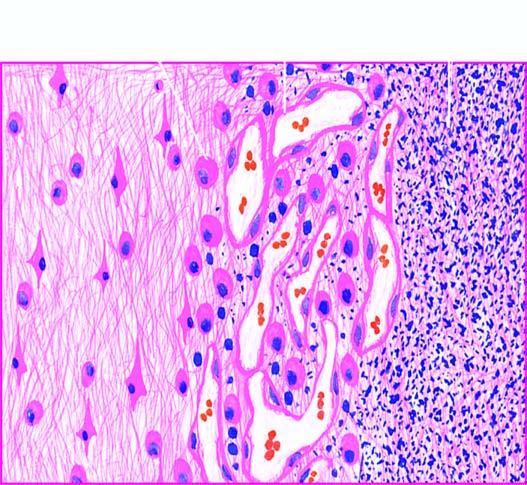does the necrosed area on right side of the field show a cystic space containing cell debris, while the surrounding zone shows granulation tissue and gliosis?
Answer the question using a single word or phrase. Yes 